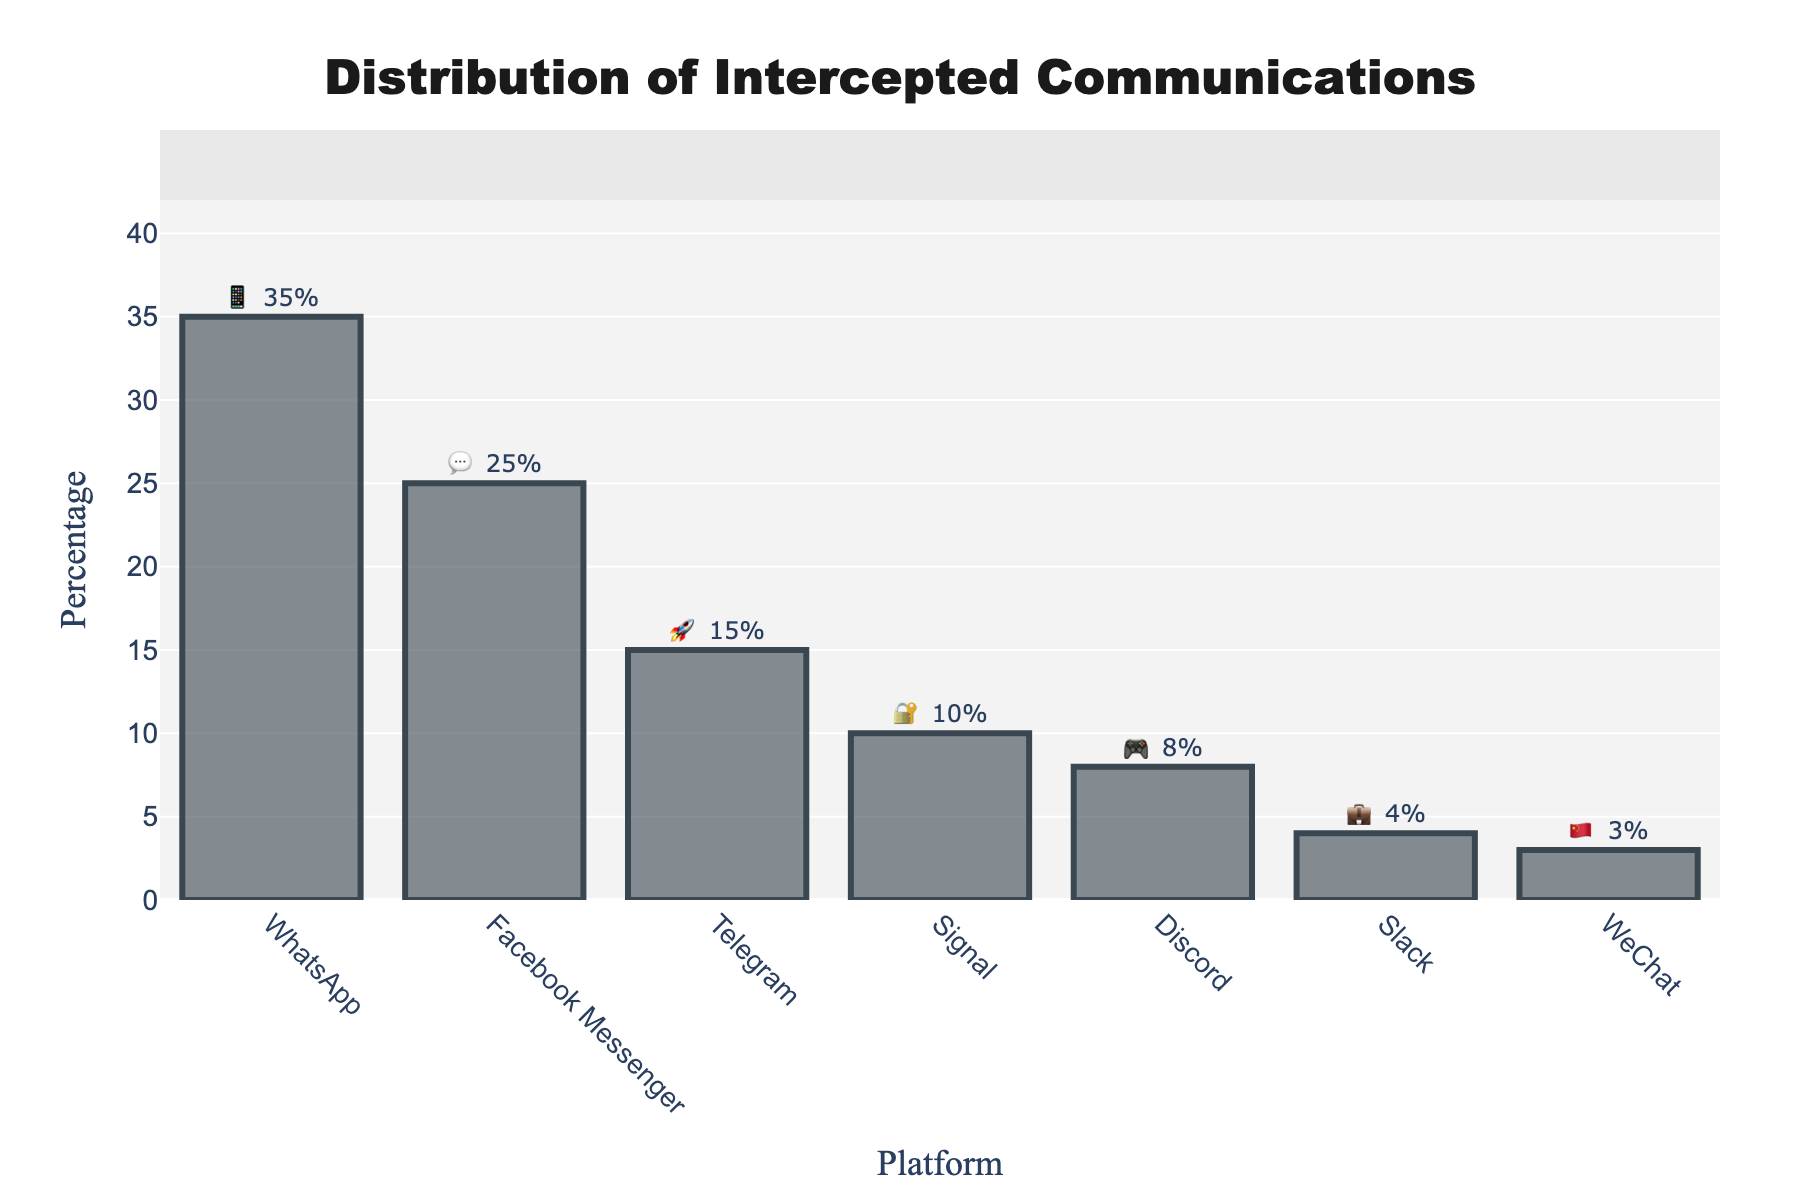what is the title of the figure? The title is usually found at the top of the figure. Looking at the top center of the figure, the title reads "Distribution of Intercepted Communications" in bold, large font.
Answer: Distribution of Intercepted Communications which platform has the highest percentage of intercepted communications? To determine this, identify the bar representing the platform with the highest percentage. The tallest bar is labeled with an emoji and a percentage, indicating the highest value.
Answer: WhatsApp how many platforms have a percentage greater than 10%? Count the bars that have a percentage greater than 10% labeled next to them. Those bars represent platforms with higher interception rates.
Answer: Four what is the combined percentage of Facebook Messenger, Telegram, and Signal? Add the percentage values of Facebook Messenger (25%), Telegram (15%), and Signal (10%) together for the combined percentage. 25 + 15 + 10 = 50.
Answer: 50% which platform has the smallest percentage? Identify the bar with the smallest height and label. The platform with the smallest value will be the one with the shortest bar.
Answer: WeChat what is the difference in percentage between the highest and lowest platforms? Find the percentage of the highest platform (WhatsApp: 35%) and the lowest platform (WeChat: 3%), then calculate the difference by subtracting the lower from the higher. 35 - 3 = 32.
Answer: 32% how many platforms are represented in total on the figure? Count the number of distinct bars or labels on the x-axis. Each label corresponds to a different platform.
Answer: Seven which platforms have emojis related to communication or messaging? Look at the emojis associated with each platform and identify which ones suggest communication or messaging (e.g., speech bubbles, phones).
Answer: Facebook Messenger (💬), WhatsApp (📱) what percentage of communications are intercepted from platforms related to business or professional use? Identify the platforms related to business use (Slack: 4%) and note their percentage. Slack is the only business-related platform.
Answer: 4% how many platforms have a higher intercepted percentage than Discord? Compare the percentage values of all platforms to Discord's (8%). Count the platforms with values greater than 8%.
Answer: Four 